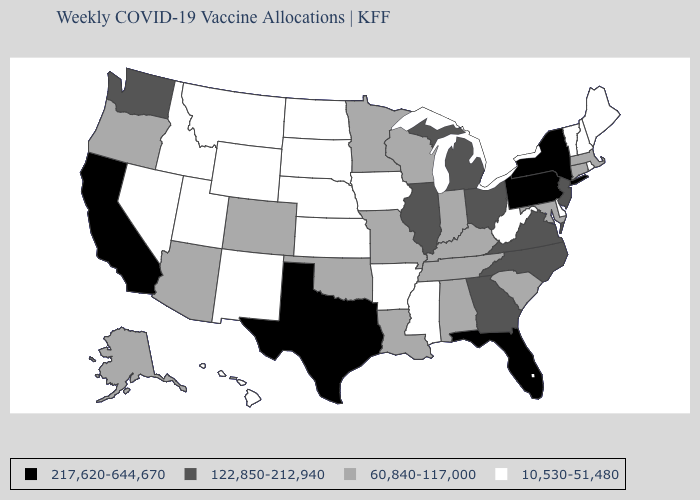What is the value of Alabama?
Write a very short answer. 60,840-117,000. What is the highest value in the USA?
Short answer required. 217,620-644,670. What is the value of Oregon?
Write a very short answer. 60,840-117,000. Does Pennsylvania have the lowest value in the Northeast?
Concise answer only. No. What is the value of Michigan?
Be succinct. 122,850-212,940. What is the value of New Jersey?
Be succinct. 122,850-212,940. What is the value of Arkansas?
Short answer required. 10,530-51,480. What is the lowest value in the USA?
Keep it brief. 10,530-51,480. What is the value of Minnesota?
Keep it brief. 60,840-117,000. Does North Carolina have a lower value than Georgia?
Give a very brief answer. No. Does the first symbol in the legend represent the smallest category?
Give a very brief answer. No. Which states hav the highest value in the West?
Be succinct. California. 